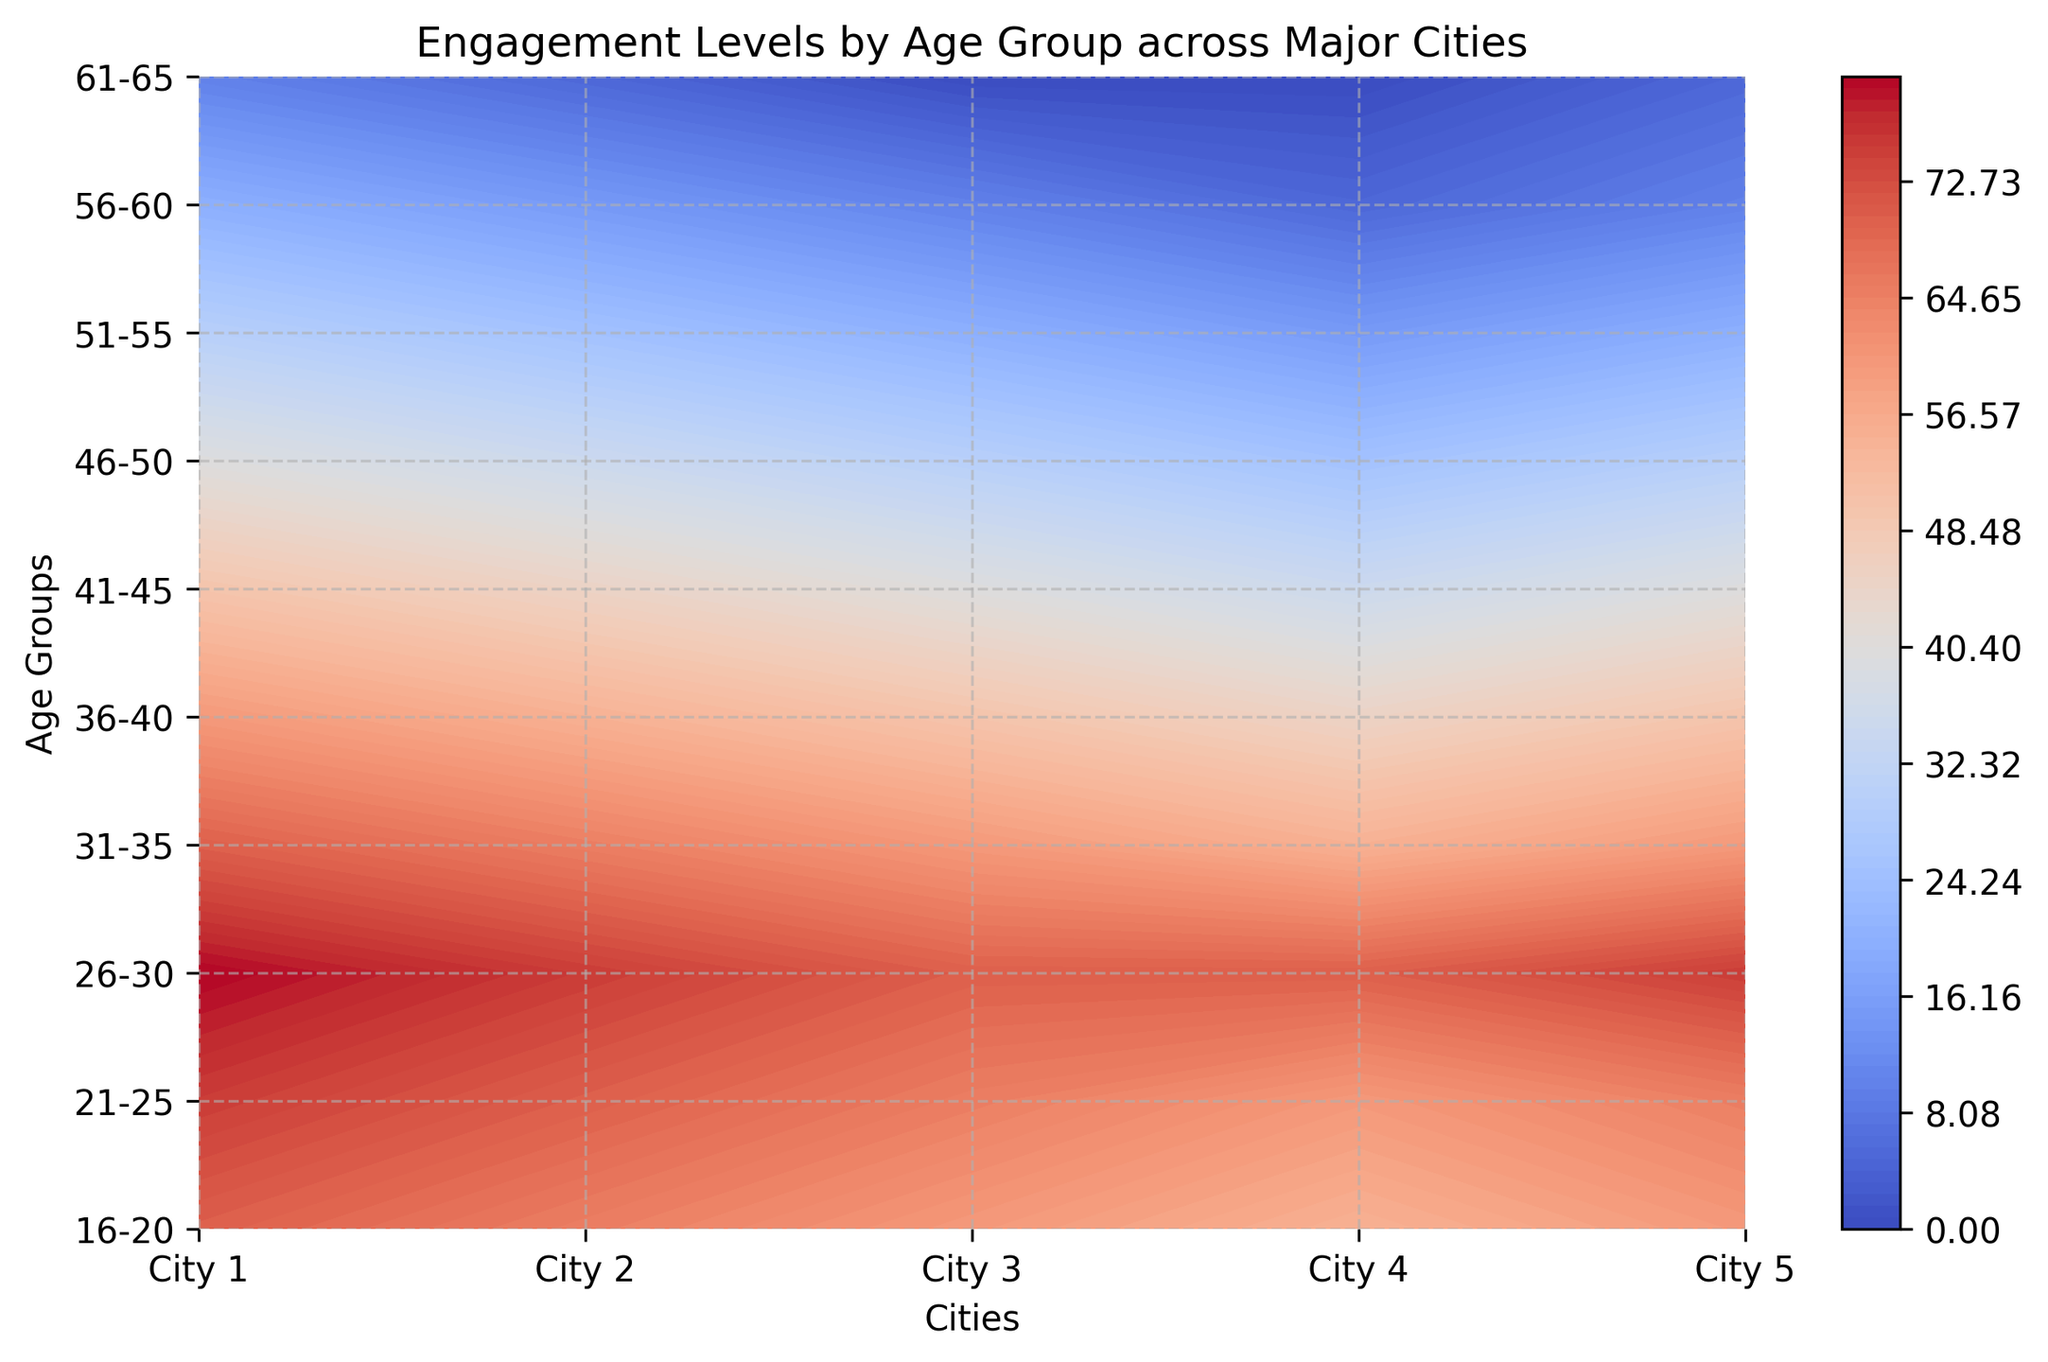What age group has the highest engagement in City 3? In the figure, locate the contour representing City 3 and observe the color intensity levels for each age group. The highest engagement level for City 3 is indicated by the most intense shade
Answer: 26-30 Which city shows the lowest engagement for the 41-45 age group? On the contour plot, find the engagement levels for the 41-45 age group across all cities. The city with the lowest intensity shade represents the lowest engagement level
Answer: City 3 and City 4 Which city has the most consistent engagement levels across all age groups? Look at the contour lines for each city. The city with the least variation in color intensity across age groups indicates the most consistency
Answer: City 5 What is the average engagement level for the 31-35 age group across all cities? To calculate the average, sum the engagement levels for the 31-35 age group in each city and divide by the number of cities: (70 + 65 + 60 + 55 + 60)/5 = 62
Answer: 62 Is there a noticeable drop in engagement levels for any specific age group across all cities? Observe the color gradients and contour lines for each age group across all cities to spot a significant decrease. The 51-55 age group shows a sharp decline in intensity
Answer: 51-55 Which age group has the highest variation in engagement levels across cities? Compare the color intensities of each age group across all cities. Identify which age group displays the most variety of shades, indicating the highest variation
Answer: 26-30 How does the engagement level for the 46-50 age group in City 2 compare to that in City 4? Locate the contour shades for the 46-50 age group in City 2 and City 4 and compare them. City 2 has a higher engagement level than City 4
Answer: City 2 has a higher engagement level What city shows the highest engagement for the youngest age group? For the 16-20 age group, find which city has the most intense color, indicating the highest engagement level
Answer: City 1 How does the engagement level for the 51-55 age group compare to the 21-25 age group in City 5? Observe the color intensities for City 5 across the two age groups. The 21-25 age group shows a higher engagement level compared to the 51-55 age group
Answer: 21-25 has higher engagement level 